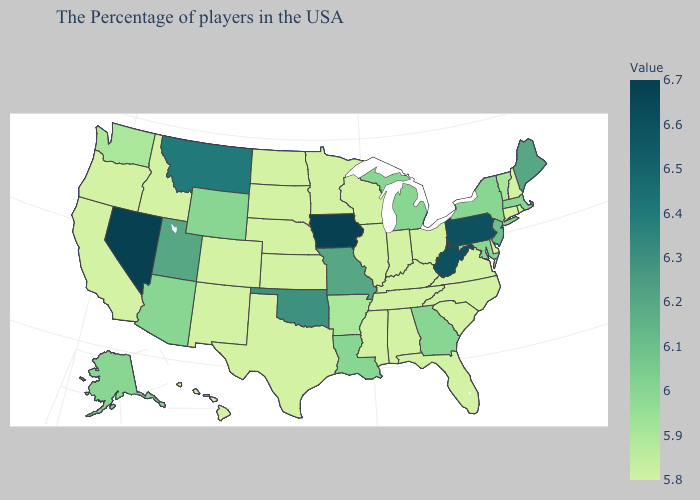Among the states that border Minnesota , which have the highest value?
Write a very short answer. Iowa. Which states hav the highest value in the West?
Concise answer only. Nevada. Does South Dakota have a lower value than Arizona?
Concise answer only. Yes. Does Vermont have the lowest value in the USA?
Answer briefly. No. 